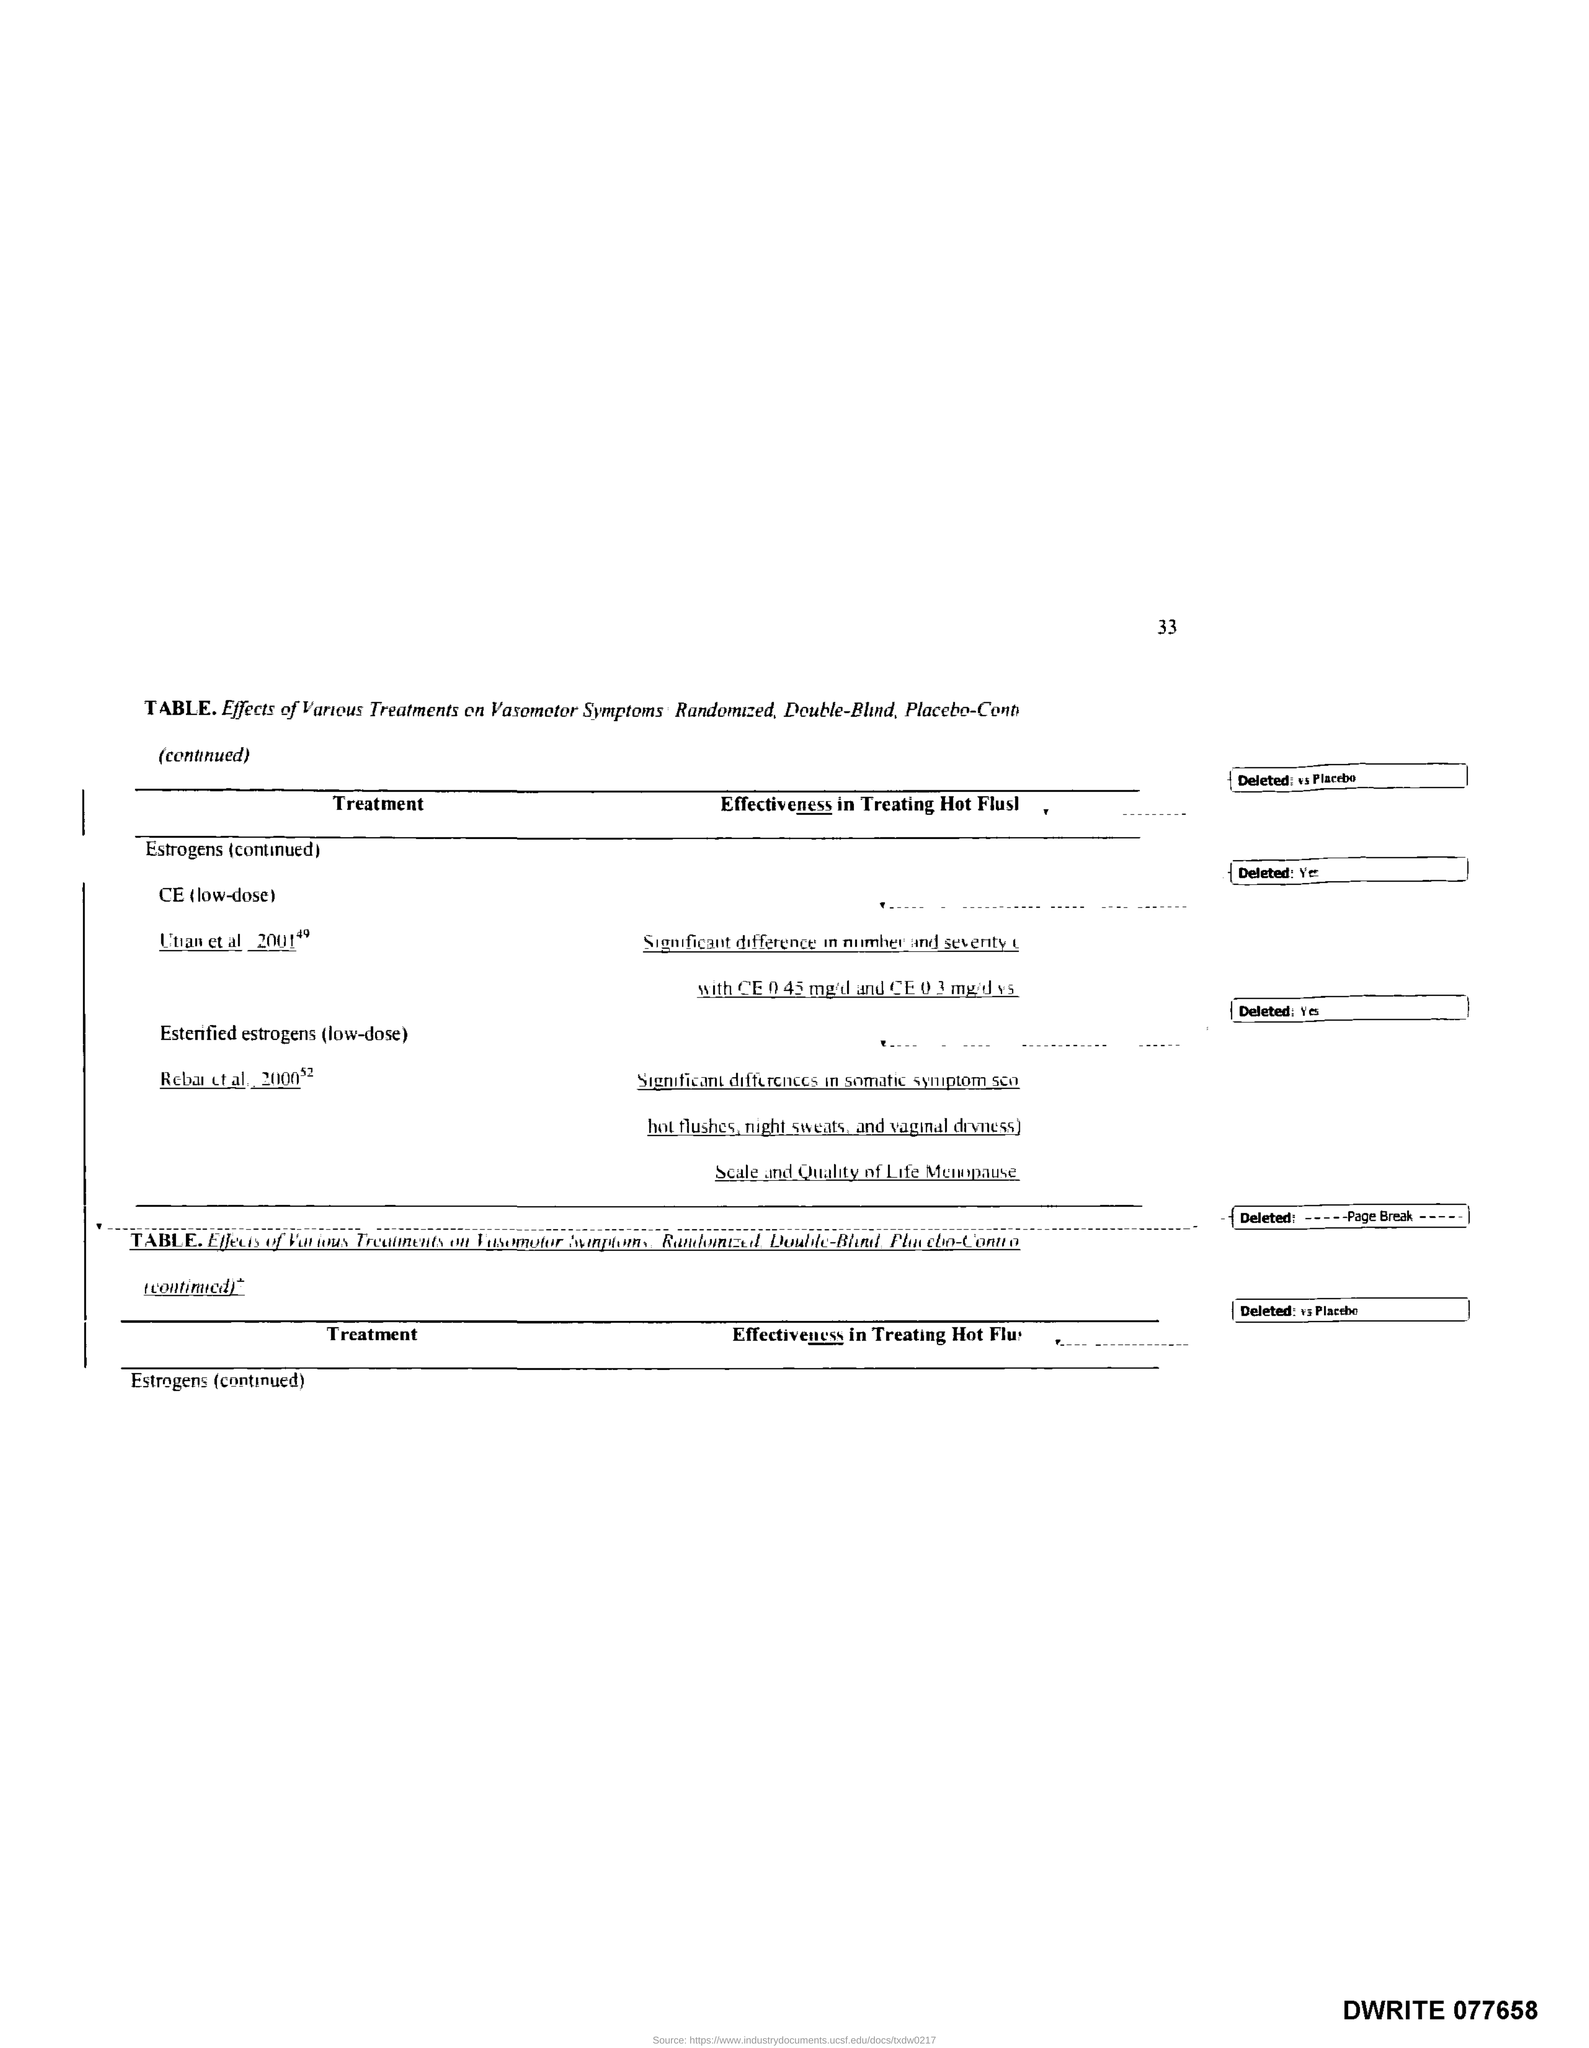What is the Page Number?
Ensure brevity in your answer.  33. 